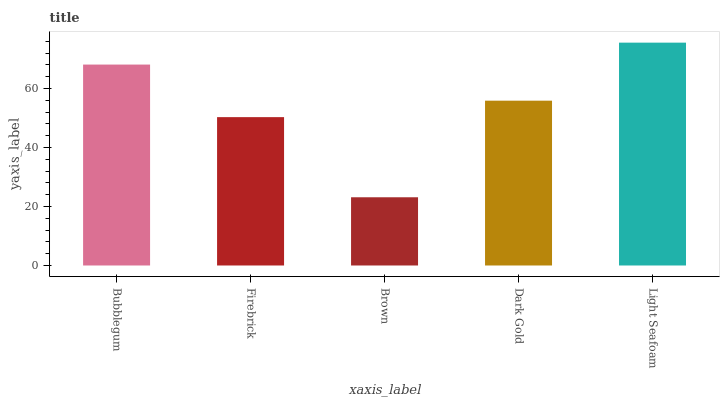Is Brown the minimum?
Answer yes or no. Yes. Is Light Seafoam the maximum?
Answer yes or no. Yes. Is Firebrick the minimum?
Answer yes or no. No. Is Firebrick the maximum?
Answer yes or no. No. Is Bubblegum greater than Firebrick?
Answer yes or no. Yes. Is Firebrick less than Bubblegum?
Answer yes or no. Yes. Is Firebrick greater than Bubblegum?
Answer yes or no. No. Is Bubblegum less than Firebrick?
Answer yes or no. No. Is Dark Gold the high median?
Answer yes or no. Yes. Is Dark Gold the low median?
Answer yes or no. Yes. Is Bubblegum the high median?
Answer yes or no. No. Is Brown the low median?
Answer yes or no. No. 